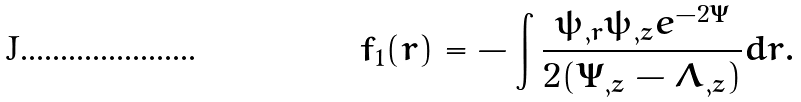<formula> <loc_0><loc_0><loc_500><loc_500>f _ { 1 } ( r ) = - \int \frac { \psi _ { , r } \psi _ { , z } e ^ { - 2 \Psi } } { 2 ( \Psi _ { , z } - \Lambda _ { , z } ) } d r .</formula> 